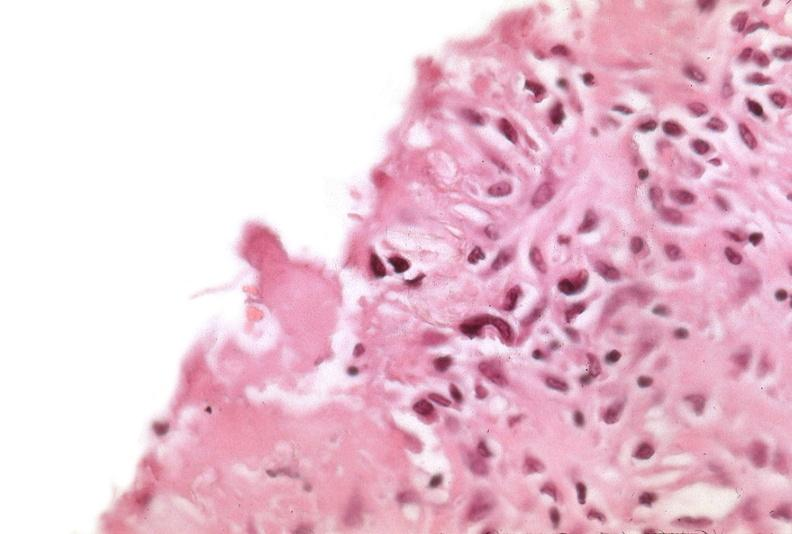does other x-rays show pleura, talc reaction?
Answer the question using a single word or phrase. No 